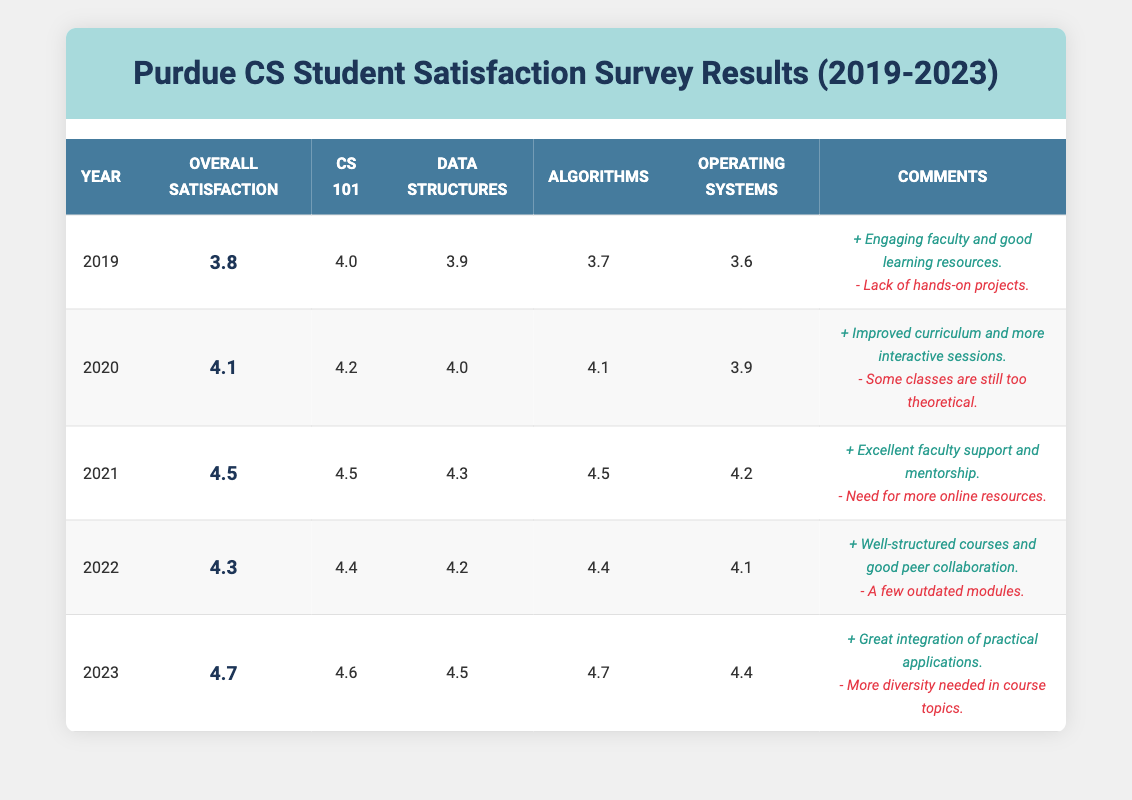What is the overall satisfaction score in 2021? The overall satisfaction score for the year 2021 is located in the table under the column "Overall Satisfaction" for that year. It reads 4.5.
Answer: 4.5 Which course had the highest feedback score in 2023? In the year 2023, the feedback scores for each course are shown individually in their respective columns. The course "Algorithms" has the highest score of 4.7.
Answer: Algorithms What was the difference in satisfaction scores between 2019 and 2023? To find the difference, subtract the satisfaction score of 2019 (3.8) from that of 2023 (4.7). Thus, 4.7 - 3.8 = 0.9.
Answer: 0.9 Did the satisfaction score increase every year from 2019 to 2023? By checking the "Overall Satisfaction" scores for each year, we find that they increased from 3.8 in 2019 to 4.7 in 2023 without a decrease in any year. Thus, the answer is yes.
Answer: Yes What is the average satisfaction score for the courses in 2020? To find the average, sum the satisfaction scores for each course in 2020: (4.2 + 4.0 + 4.1 + 3.9) = 16.2. Then divide by the number of courses (4), so 16.2 / 4 = 4.05.
Answer: 4.05 What percentage of years had positive overall comments mentioning "hands-on projects"? Check the comments for each year. Only in 2019 do the comments specifically mention "hands-on projects" negatively. Out of 5 years, that’s 1 year, which gives us (1/5)*100% = 20%.
Answer: 20% In how many years did the Computer Science 101 course score higher than the overall satisfaction score? Analyze the data for Computer Science 101 across the years. It scored higher than the overall score in 2020 (4.2 vs 4.1) and 2021 (4.5 vs 4.5, tie is not counted). This occurred 2 times.
Answer: 2 What overall trend can be observed in the satisfaction scores from 2019 to 2023? By reviewing the "Overall Satisfaction" scores from the table, we see a consistent increase from 3.8 in 2019 to 4.7 in 2023, with no decreases and a general upward trend.
Answer: Increasing trend 